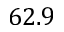Convert formula to latex. <formula><loc_0><loc_0><loc_500><loc_500>6 2 . 9</formula> 